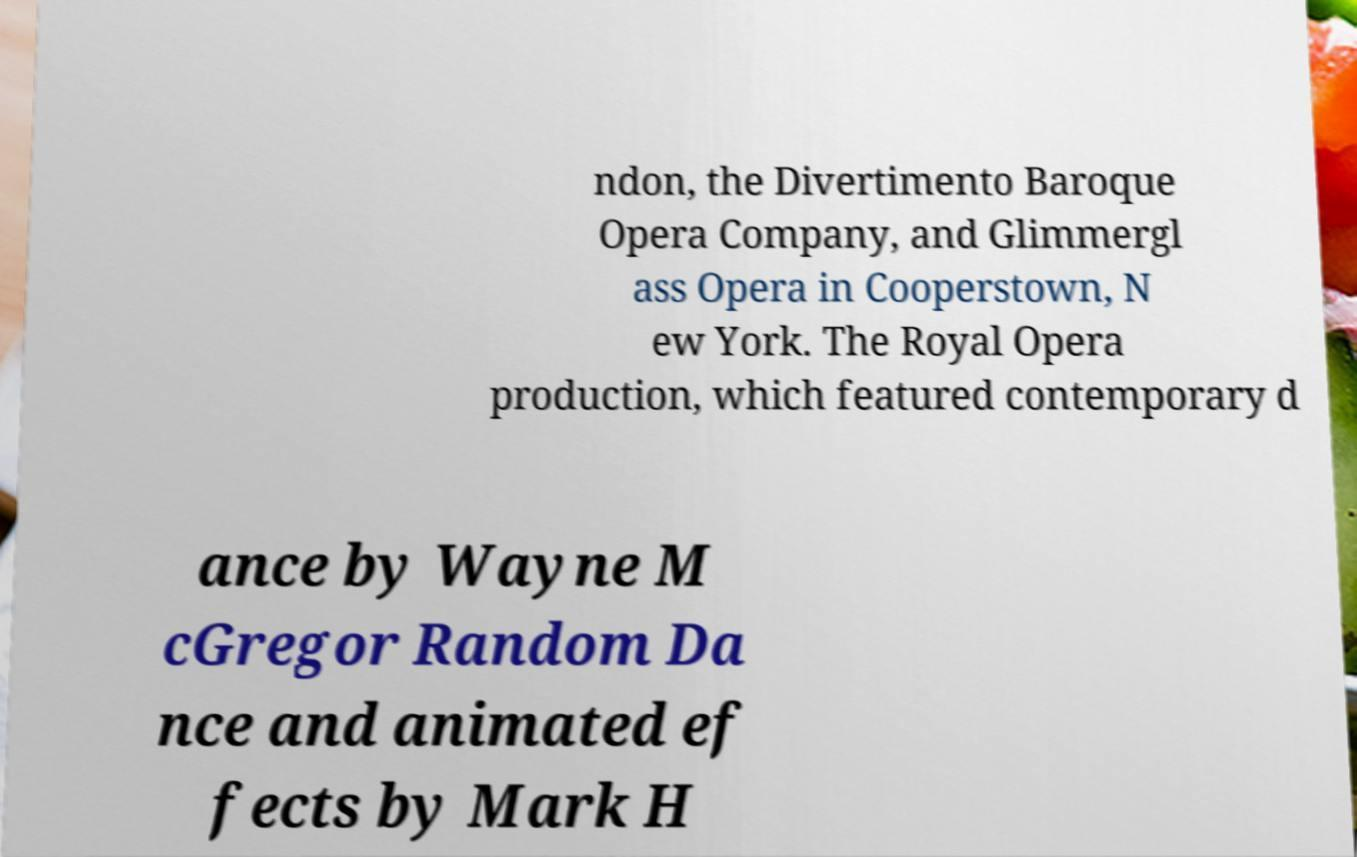Could you extract and type out the text from this image? ndon, the Divertimento Baroque Opera Company, and Glimmergl ass Opera in Cooperstown, N ew York. The Royal Opera production, which featured contemporary d ance by Wayne M cGregor Random Da nce and animated ef fects by Mark H 